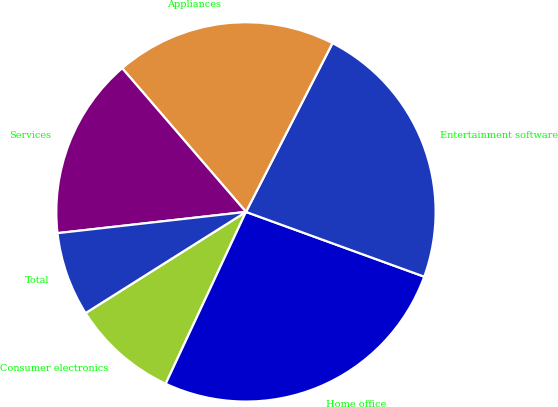Convert chart to OTSL. <chart><loc_0><loc_0><loc_500><loc_500><pie_chart><fcel>Consumer electronics<fcel>Home office<fcel>Entertainment software<fcel>Appliances<fcel>Services<fcel>Total<nl><fcel>9.09%<fcel>26.41%<fcel>23.01%<fcel>18.86%<fcel>15.47%<fcel>7.17%<nl></chart> 